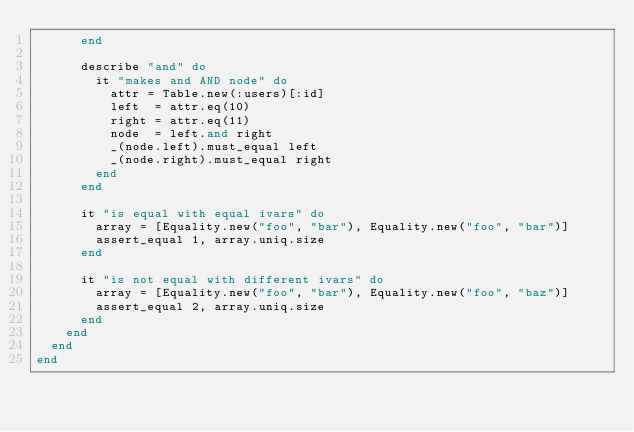<code> <loc_0><loc_0><loc_500><loc_500><_Ruby_>      end

      describe "and" do
        it "makes and AND node" do
          attr = Table.new(:users)[:id]
          left  = attr.eq(10)
          right = attr.eq(11)
          node  = left.and right
          _(node.left).must_equal left
          _(node.right).must_equal right
        end
      end

      it "is equal with equal ivars" do
        array = [Equality.new("foo", "bar"), Equality.new("foo", "bar")]
        assert_equal 1, array.uniq.size
      end

      it "is not equal with different ivars" do
        array = [Equality.new("foo", "bar"), Equality.new("foo", "baz")]
        assert_equal 2, array.uniq.size
      end
    end
  end
end
</code> 